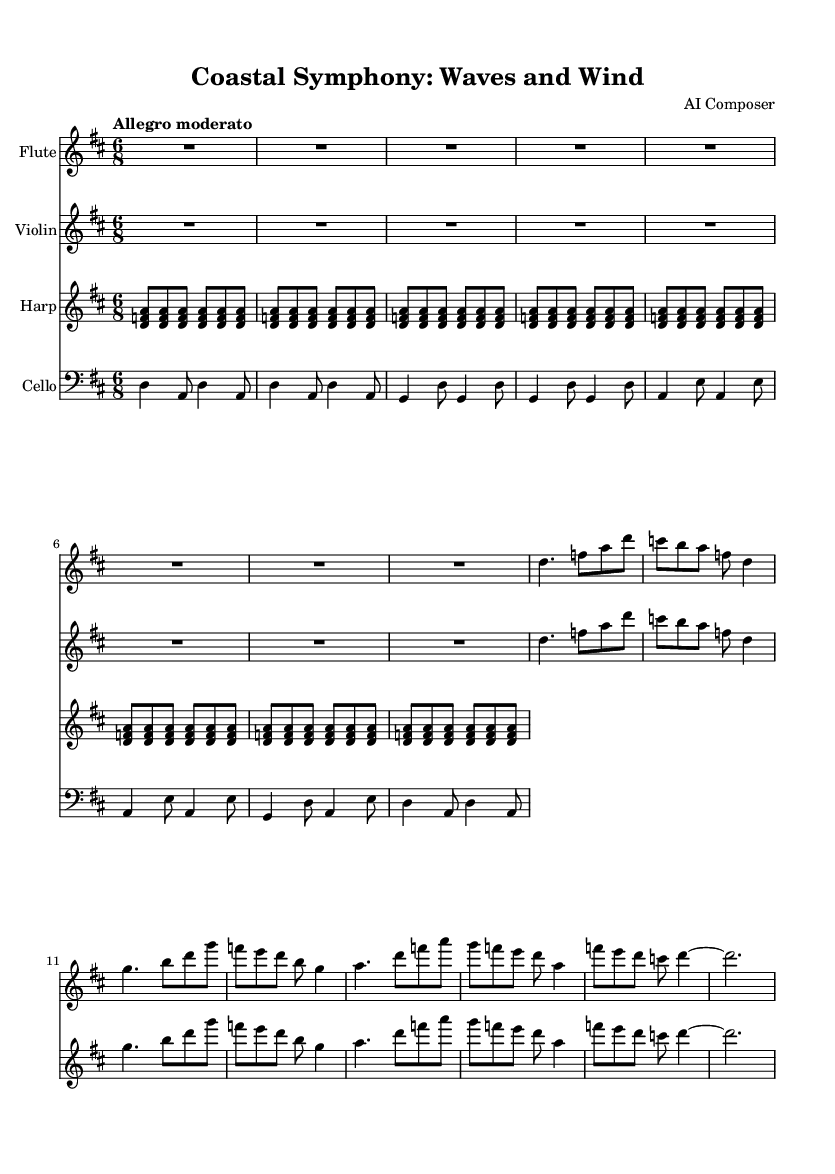What is the key signature of this music? The key signature is indicated at the beginning of the staff, showing two sharps (F# and C#), which defines the key of D major.
Answer: D major What is the time signature of this music? The time signature is visible at the beginning of the score, showing a 6 over 8, indicating the piece is in compound time with six eighth notes per measure.
Answer: 6/8 What is the tempo marking of this piece? The tempo marking is written above the staff and specifies "Allegro moderato," which indicates a moderate and lively pace.
Answer: Allegro moderato How many different instruments are featured in this symphony? By counting the different staves appearing in the score, there are four staves representing the flute, violin, harp, and cello, indicating four instruments are featured.
Answer: Four Which instrument has the highest pitch in this symphony? Comparing the ranges of the instruments, the flute is the highest sounding instrument in this ensemble, as it typically plays notes in the upper registers.
Answer: Flute What kind of musical sections are repeated in this piece? Looking at the harp part, there is a repeated sequence of the notes forming a repetitive pattern labeled as "repeat unfold," indicating repeated sections in its rhythm.
Answer: Repetitive pattern Which notes are emphasized in the cello part? Observing the cello part, the notes D and A appear prominently, suggesting that they are the emphasized anchor notes throughout the sections.
Answer: D and A 